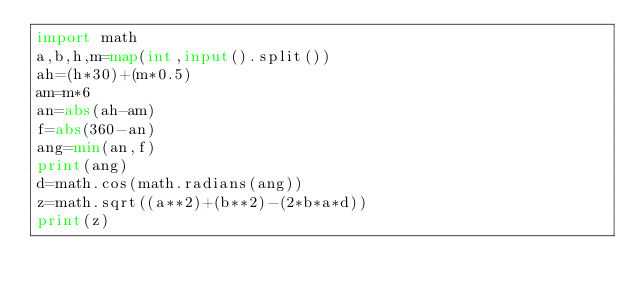<code> <loc_0><loc_0><loc_500><loc_500><_Python_>import math
a,b,h,m=map(int,input().split()) 
ah=(h*30)+(m*0.5)
am=m*6
an=abs(ah-am)
f=abs(360-an)
ang=min(an,f)
print(ang)
d=math.cos(math.radians(ang))
z=math.sqrt((a**2)+(b**2)-(2*b*a*d))
print(z)</code> 